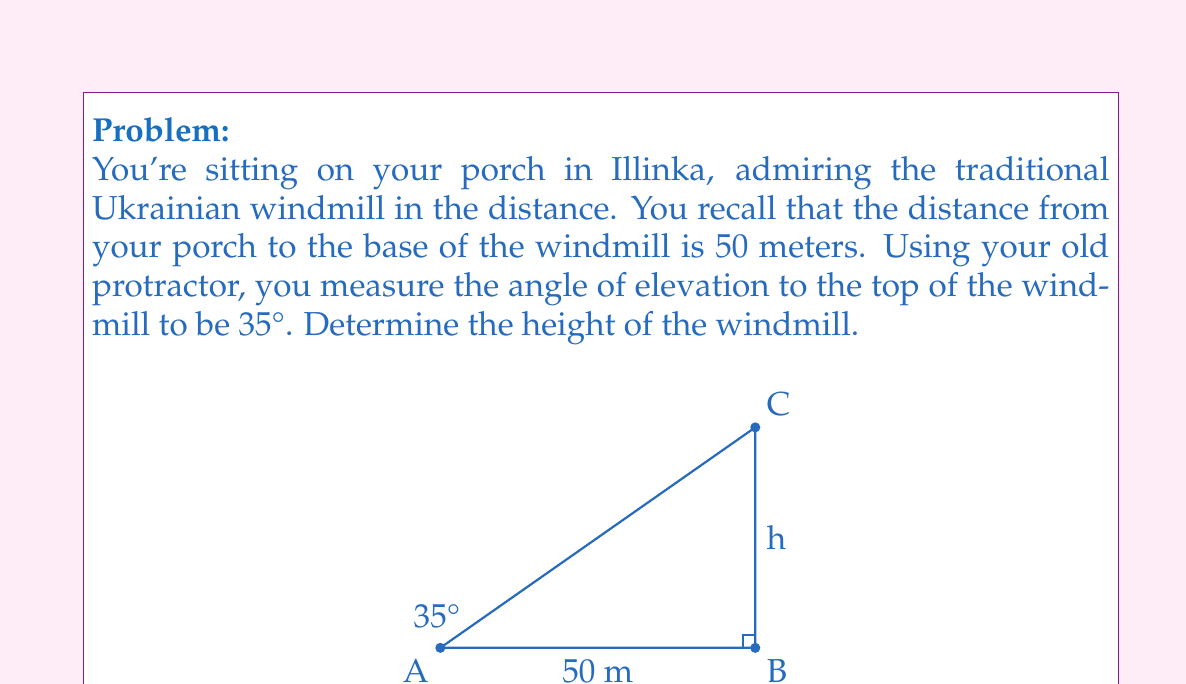What is the answer to this math problem? Let's approach this step-by-step using trigonometry:

1) In the right-angled triangle formed, we know:
   - The adjacent side (distance to the windmill) = 50 meters
   - The angle of elevation = 35°
   - We need to find the opposite side (height of the windmill)

2) The trigonometric ratio that relates the opposite side to the adjacent side is tangent:

   $$\tan \theta = \frac{\text{opposite}}{\text{adjacent}}$$

3) Let's call the height of the windmill $h$. We can write:

   $$\tan 35° = \frac{h}{50}$$

4) To find $h$, we multiply both sides by 50:

   $$h = 50 \tan 35°$$

5) Now, we can use a calculator to compute this:

   $$h = 50 \times \tan 35° \approx 50 \times 0.7002 \approx 35.01 \text{ meters}$$

6) Rounding to the nearest meter:

   $$h \approx 35 \text{ meters}$$

Thus, the height of the traditional Ukrainian windmill is approximately 35 meters.
Answer: $35 \text{ meters}$ 